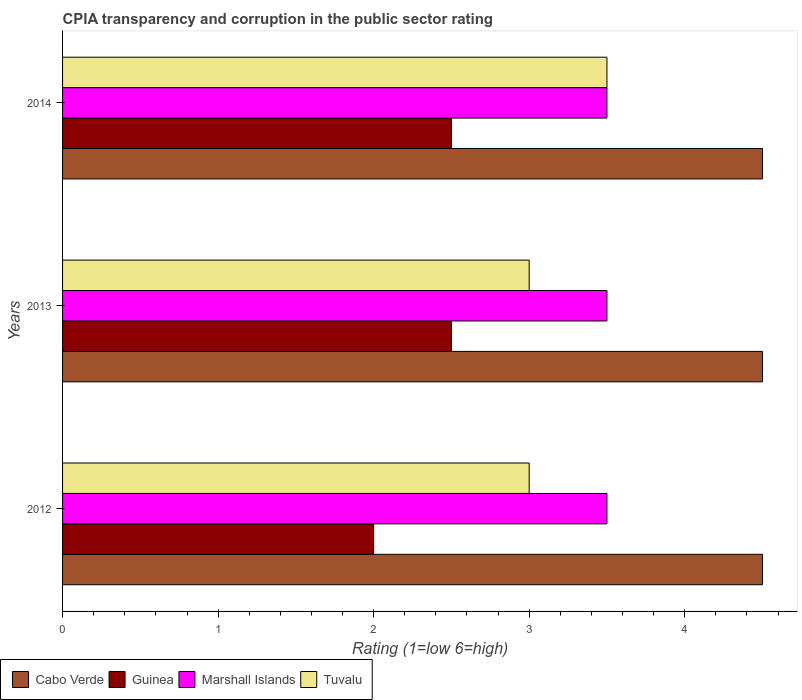How many different coloured bars are there?
Make the answer very short. 4. How many groups of bars are there?
Offer a very short reply. 3. In how many cases, is the number of bars for a given year not equal to the number of legend labels?
Make the answer very short. 0. What is the CPIA rating in Tuvalu in 2012?
Your answer should be very brief. 3. In which year was the CPIA rating in Marshall Islands minimum?
Give a very brief answer. 2012. In the year 2012, what is the difference between the CPIA rating in Cabo Verde and CPIA rating in Tuvalu?
Your answer should be very brief. 1.5. Is the CPIA rating in Cabo Verde in 2012 less than that in 2013?
Offer a terse response. No. What is the difference between the highest and the second highest CPIA rating in Marshall Islands?
Give a very brief answer. 0. What is the difference between the highest and the lowest CPIA rating in Cabo Verde?
Ensure brevity in your answer.  0. In how many years, is the CPIA rating in Guinea greater than the average CPIA rating in Guinea taken over all years?
Ensure brevity in your answer.  2. Is the sum of the CPIA rating in Tuvalu in 2013 and 2014 greater than the maximum CPIA rating in Cabo Verde across all years?
Ensure brevity in your answer.  Yes. Is it the case that in every year, the sum of the CPIA rating in Cabo Verde and CPIA rating in Guinea is greater than the sum of CPIA rating in Marshall Islands and CPIA rating in Tuvalu?
Your answer should be very brief. Yes. What does the 3rd bar from the top in 2014 represents?
Offer a very short reply. Guinea. What does the 3rd bar from the bottom in 2014 represents?
Keep it short and to the point. Marshall Islands. How many years are there in the graph?
Make the answer very short. 3. What is the difference between two consecutive major ticks on the X-axis?
Keep it short and to the point. 1. Are the values on the major ticks of X-axis written in scientific E-notation?
Offer a very short reply. No. Does the graph contain any zero values?
Offer a terse response. No. Does the graph contain grids?
Offer a very short reply. No. Where does the legend appear in the graph?
Offer a terse response. Bottom left. How many legend labels are there?
Provide a short and direct response. 4. What is the title of the graph?
Keep it short and to the point. CPIA transparency and corruption in the public sector rating. What is the label or title of the X-axis?
Provide a short and direct response. Rating (1=low 6=high). What is the label or title of the Y-axis?
Give a very brief answer. Years. What is the Rating (1=low 6=high) in Guinea in 2012?
Your response must be concise. 2. What is the Rating (1=low 6=high) of Marshall Islands in 2012?
Your response must be concise. 3.5. What is the Rating (1=low 6=high) of Guinea in 2013?
Give a very brief answer. 2.5. What is the Rating (1=low 6=high) in Marshall Islands in 2013?
Ensure brevity in your answer.  3.5. What is the Rating (1=low 6=high) in Cabo Verde in 2014?
Give a very brief answer. 4.5. What is the Rating (1=low 6=high) of Marshall Islands in 2014?
Keep it short and to the point. 3.5. Across all years, what is the maximum Rating (1=low 6=high) in Guinea?
Make the answer very short. 2.5. Across all years, what is the maximum Rating (1=low 6=high) of Marshall Islands?
Give a very brief answer. 3.5. Across all years, what is the minimum Rating (1=low 6=high) in Cabo Verde?
Provide a short and direct response. 4.5. Across all years, what is the minimum Rating (1=low 6=high) of Tuvalu?
Your answer should be compact. 3. What is the total Rating (1=low 6=high) of Cabo Verde in the graph?
Ensure brevity in your answer.  13.5. What is the total Rating (1=low 6=high) of Marshall Islands in the graph?
Provide a short and direct response. 10.5. What is the difference between the Rating (1=low 6=high) of Guinea in 2012 and that in 2014?
Give a very brief answer. -0.5. What is the difference between the Rating (1=low 6=high) in Tuvalu in 2012 and that in 2014?
Your answer should be compact. -0.5. What is the difference between the Rating (1=low 6=high) in Cabo Verde in 2013 and that in 2014?
Keep it short and to the point. 0. What is the difference between the Rating (1=low 6=high) of Guinea in 2012 and the Rating (1=low 6=high) of Marshall Islands in 2013?
Ensure brevity in your answer.  -1.5. What is the difference between the Rating (1=low 6=high) of Marshall Islands in 2012 and the Rating (1=low 6=high) of Tuvalu in 2013?
Provide a succinct answer. 0.5. What is the difference between the Rating (1=low 6=high) in Cabo Verde in 2012 and the Rating (1=low 6=high) in Guinea in 2014?
Give a very brief answer. 2. What is the difference between the Rating (1=low 6=high) in Cabo Verde in 2012 and the Rating (1=low 6=high) in Tuvalu in 2014?
Your response must be concise. 1. What is the difference between the Rating (1=low 6=high) of Guinea in 2012 and the Rating (1=low 6=high) of Marshall Islands in 2014?
Your response must be concise. -1.5. What is the difference between the Rating (1=low 6=high) in Guinea in 2012 and the Rating (1=low 6=high) in Tuvalu in 2014?
Provide a succinct answer. -1.5. What is the difference between the Rating (1=low 6=high) in Marshall Islands in 2012 and the Rating (1=low 6=high) in Tuvalu in 2014?
Your response must be concise. 0. What is the difference between the Rating (1=low 6=high) in Cabo Verde in 2013 and the Rating (1=low 6=high) in Guinea in 2014?
Provide a short and direct response. 2. What is the difference between the Rating (1=low 6=high) of Cabo Verde in 2013 and the Rating (1=low 6=high) of Marshall Islands in 2014?
Provide a short and direct response. 1. What is the difference between the Rating (1=low 6=high) of Guinea in 2013 and the Rating (1=low 6=high) of Tuvalu in 2014?
Your response must be concise. -1. What is the difference between the Rating (1=low 6=high) of Marshall Islands in 2013 and the Rating (1=low 6=high) of Tuvalu in 2014?
Offer a terse response. 0. What is the average Rating (1=low 6=high) in Cabo Verde per year?
Your response must be concise. 4.5. What is the average Rating (1=low 6=high) of Guinea per year?
Offer a terse response. 2.33. What is the average Rating (1=low 6=high) of Tuvalu per year?
Your answer should be very brief. 3.17. In the year 2012, what is the difference between the Rating (1=low 6=high) in Cabo Verde and Rating (1=low 6=high) in Guinea?
Keep it short and to the point. 2.5. In the year 2012, what is the difference between the Rating (1=low 6=high) in Cabo Verde and Rating (1=low 6=high) in Tuvalu?
Your response must be concise. 1.5. In the year 2012, what is the difference between the Rating (1=low 6=high) in Guinea and Rating (1=low 6=high) in Marshall Islands?
Make the answer very short. -1.5. In the year 2013, what is the difference between the Rating (1=low 6=high) in Cabo Verde and Rating (1=low 6=high) in Guinea?
Make the answer very short. 2. In the year 2013, what is the difference between the Rating (1=low 6=high) in Cabo Verde and Rating (1=low 6=high) in Marshall Islands?
Provide a short and direct response. 1. In the year 2013, what is the difference between the Rating (1=low 6=high) in Guinea and Rating (1=low 6=high) in Marshall Islands?
Your answer should be very brief. -1. In the year 2014, what is the difference between the Rating (1=low 6=high) in Cabo Verde and Rating (1=low 6=high) in Guinea?
Make the answer very short. 2. In the year 2014, what is the difference between the Rating (1=low 6=high) in Cabo Verde and Rating (1=low 6=high) in Tuvalu?
Offer a terse response. 1. In the year 2014, what is the difference between the Rating (1=low 6=high) in Guinea and Rating (1=low 6=high) in Marshall Islands?
Ensure brevity in your answer.  -1. In the year 2014, what is the difference between the Rating (1=low 6=high) of Guinea and Rating (1=low 6=high) of Tuvalu?
Offer a terse response. -1. In the year 2014, what is the difference between the Rating (1=low 6=high) in Marshall Islands and Rating (1=low 6=high) in Tuvalu?
Give a very brief answer. 0. What is the ratio of the Rating (1=low 6=high) in Marshall Islands in 2012 to that in 2013?
Provide a short and direct response. 1. What is the ratio of the Rating (1=low 6=high) in Tuvalu in 2012 to that in 2013?
Make the answer very short. 1. What is the ratio of the Rating (1=low 6=high) of Cabo Verde in 2012 to that in 2014?
Your response must be concise. 1. What is the ratio of the Rating (1=low 6=high) of Marshall Islands in 2012 to that in 2014?
Your response must be concise. 1. What is the ratio of the Rating (1=low 6=high) in Tuvalu in 2012 to that in 2014?
Your response must be concise. 0.86. What is the ratio of the Rating (1=low 6=high) of Cabo Verde in 2013 to that in 2014?
Provide a succinct answer. 1. What is the ratio of the Rating (1=low 6=high) of Guinea in 2013 to that in 2014?
Offer a very short reply. 1. What is the difference between the highest and the second highest Rating (1=low 6=high) of Cabo Verde?
Provide a short and direct response. 0. What is the difference between the highest and the second highest Rating (1=low 6=high) in Guinea?
Your answer should be compact. 0. What is the difference between the highest and the lowest Rating (1=low 6=high) in Tuvalu?
Provide a succinct answer. 0.5. 